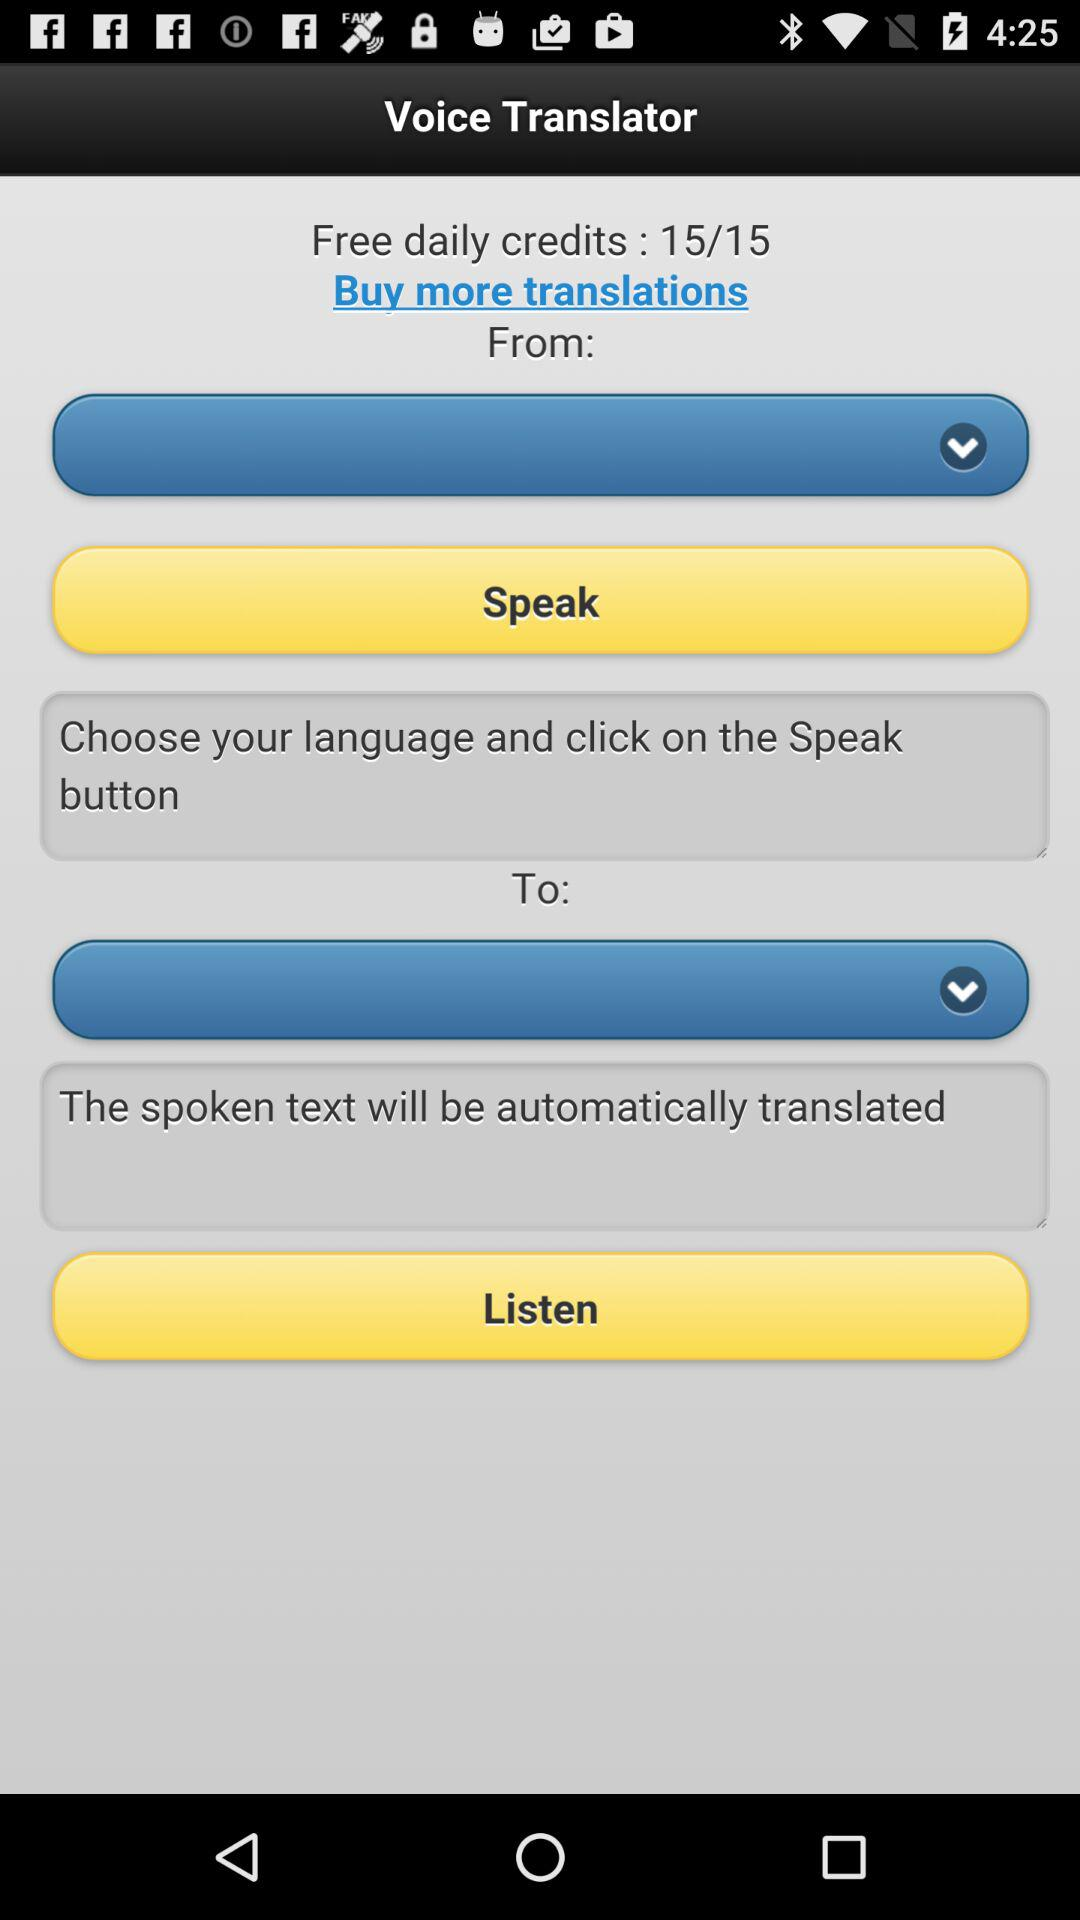How many free daily credits are available in "Voice Translator"? There are 15 free daily credits available in "Voice Translator". 